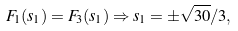Convert formula to latex. <formula><loc_0><loc_0><loc_500><loc_500>F _ { 1 } ( s _ { 1 } ) = F _ { 3 } ( s _ { 1 } ) \Rightarrow s _ { 1 } = \pm \sqrt { 3 0 } / 3 ,</formula> 